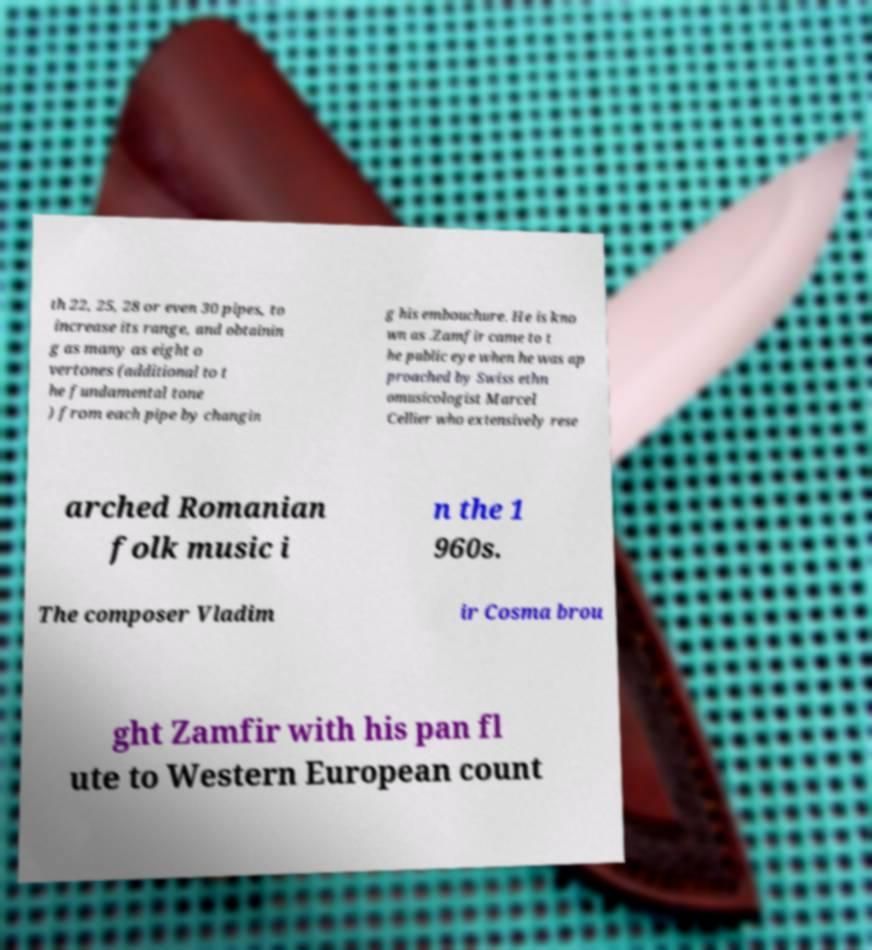Please read and relay the text visible in this image. What does it say? th 22, 25, 28 or even 30 pipes, to increase its range, and obtainin g as many as eight o vertones (additional to t he fundamental tone ) from each pipe by changin g his embouchure. He is kno wn as .Zamfir came to t he public eye when he was ap proached by Swiss ethn omusicologist Marcel Cellier who extensively rese arched Romanian folk music i n the 1 960s. The composer Vladim ir Cosma brou ght Zamfir with his pan fl ute to Western European count 